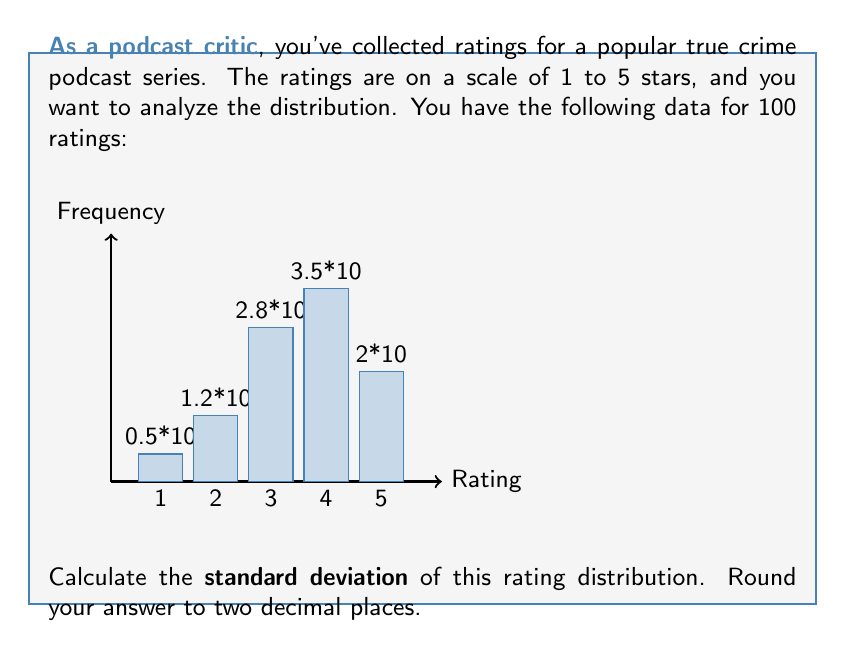Teach me how to tackle this problem. To calculate the standard deviation, we'll follow these steps:

1) First, calculate the mean (μ) of the ratings:

   $$ \mu = \frac{1 \cdot 5 + 2 \cdot 12 + 3 \cdot 28 + 4 \cdot 35 + 5 \cdot 20}{100} = 3.53 $$

2) Next, calculate the squared differences from the mean:

   For 1 star: $(1 - 3.53)^2 \cdot 5 = 32.0225$
   For 2 stars: $(2 - 3.53)^2 \cdot 12 = 28.0548$
   For 3 stars: $(3 - 3.53)^2 \cdot 28 = 7.8484$
   For 4 stars: $(4 - 3.53)^2 \cdot 35 = 7.65375$
   For 5 stars: $(5 - 3.53)^2 \cdot 20 = 43.2180$

3) Sum these squared differences:

   $$ 32.0225 + 28.0548 + 7.8484 + 7.65375 + 43.2180 = 118.79745 $$

4) Divide by n-1 (99 in this case) to get the variance:

   $$ \text{Variance} = \frac{118.79745}{99} = 1.1999742424242424 $$

5) Take the square root to get the standard deviation:

   $$ \sigma = \sqrt{1.1999742424242424} = 1.0954335464914534 $$

6) Rounding to two decimal places:

   $$ \sigma \approx 1.10 $$
Answer: 1.10 